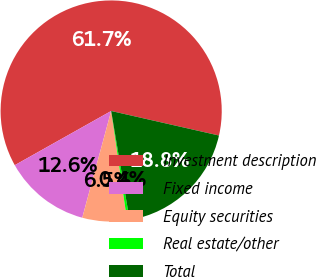Convert chart. <chart><loc_0><loc_0><loc_500><loc_500><pie_chart><fcel>Investment description<fcel>Fixed income<fcel>Equity securities<fcel>Real estate/other<fcel>Total<nl><fcel>61.71%<fcel>12.64%<fcel>6.51%<fcel>0.37%<fcel>18.77%<nl></chart> 